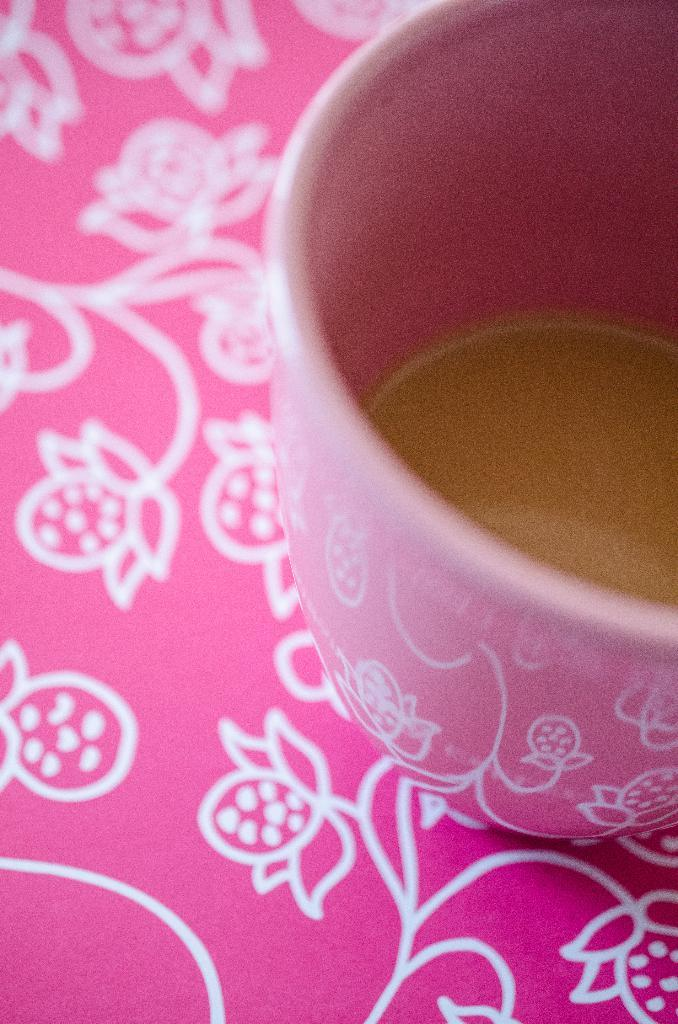What piece of furniture is present in the image? There is a table in the image. What object is placed on the table? There is a cup on the table. What is inside the cup? The cup contains coffee. What type of silk material is draped over the table in the image? There is no silk material present in the image; it only features a table, a cup, and coffee. 